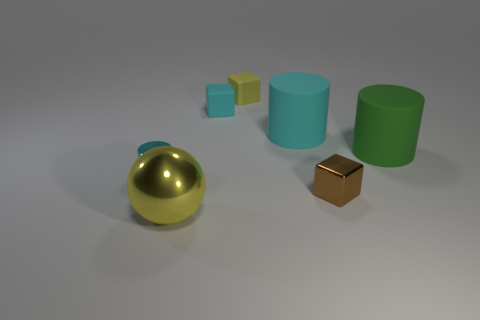Are there fewer small matte cubes that are to the left of the yellow sphere than brown metallic things behind the small brown block?
Your answer should be very brief. No. Is there any other thing that is the same shape as the tiny cyan metal object?
Offer a terse response. Yes. What material is the thing that is the same color as the big sphere?
Your answer should be compact. Rubber. What number of tiny yellow rubber blocks are on the right side of the small object that is in front of the tiny metal thing that is on the left side of the yellow shiny object?
Offer a very short reply. 0. There is a big metal object; what number of big objects are behind it?
Keep it short and to the point. 2. What number of small cylinders have the same material as the brown block?
Keep it short and to the point. 1. There is a small thing that is made of the same material as the brown cube; what color is it?
Provide a succinct answer. Cyan. There is a large cylinder behind the matte thing that is in front of the cyan cylinder that is right of the large yellow sphere; what is its material?
Make the answer very short. Rubber. There is a yellow thing that is to the right of the yellow metal thing; is its size the same as the small cyan matte block?
Provide a succinct answer. Yes. How many tiny things are brown metal blocks or yellow things?
Ensure brevity in your answer.  2. 